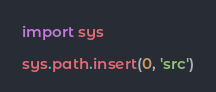<code> <loc_0><loc_0><loc_500><loc_500><_Python_>import sys

sys.path.insert(0, 'src')
</code> 